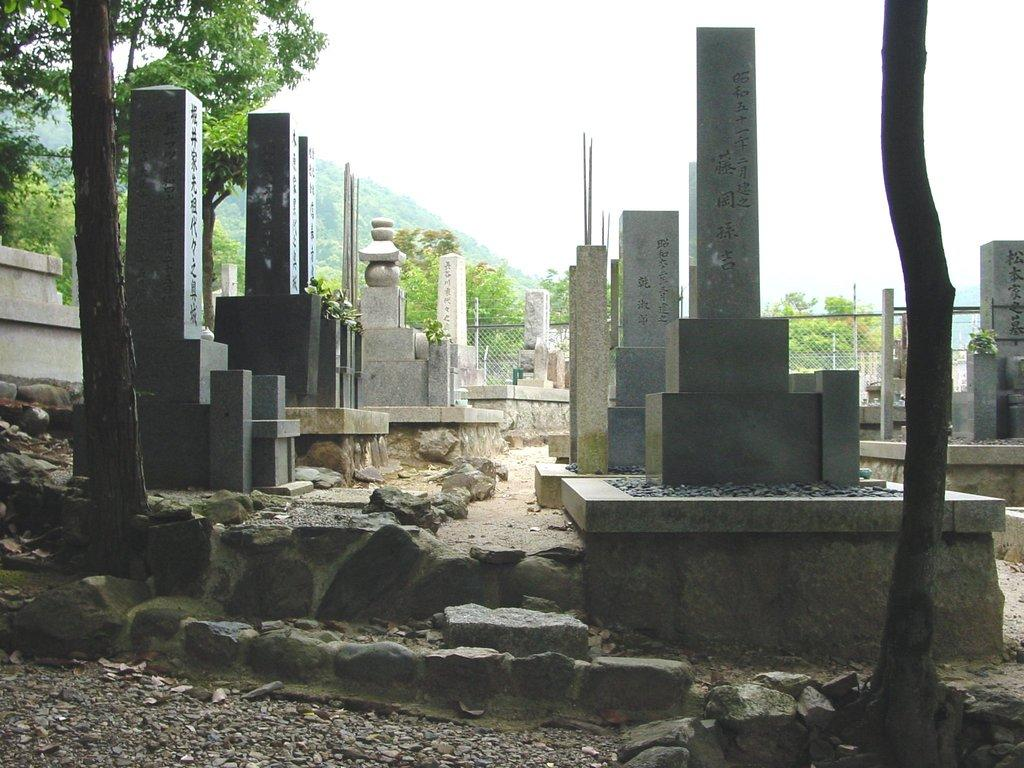What is the main subject in the center of the image? There are headstones in the center of the image. What can be seen in the background of the image? There are trees in the background of the image. Who is the owner of the slope in the image? There is no slope present in the image, and therefore no owner can be identified. What riddle can be solved by looking at the headstones in the image? There is no riddle associated with the headstones in the image. 